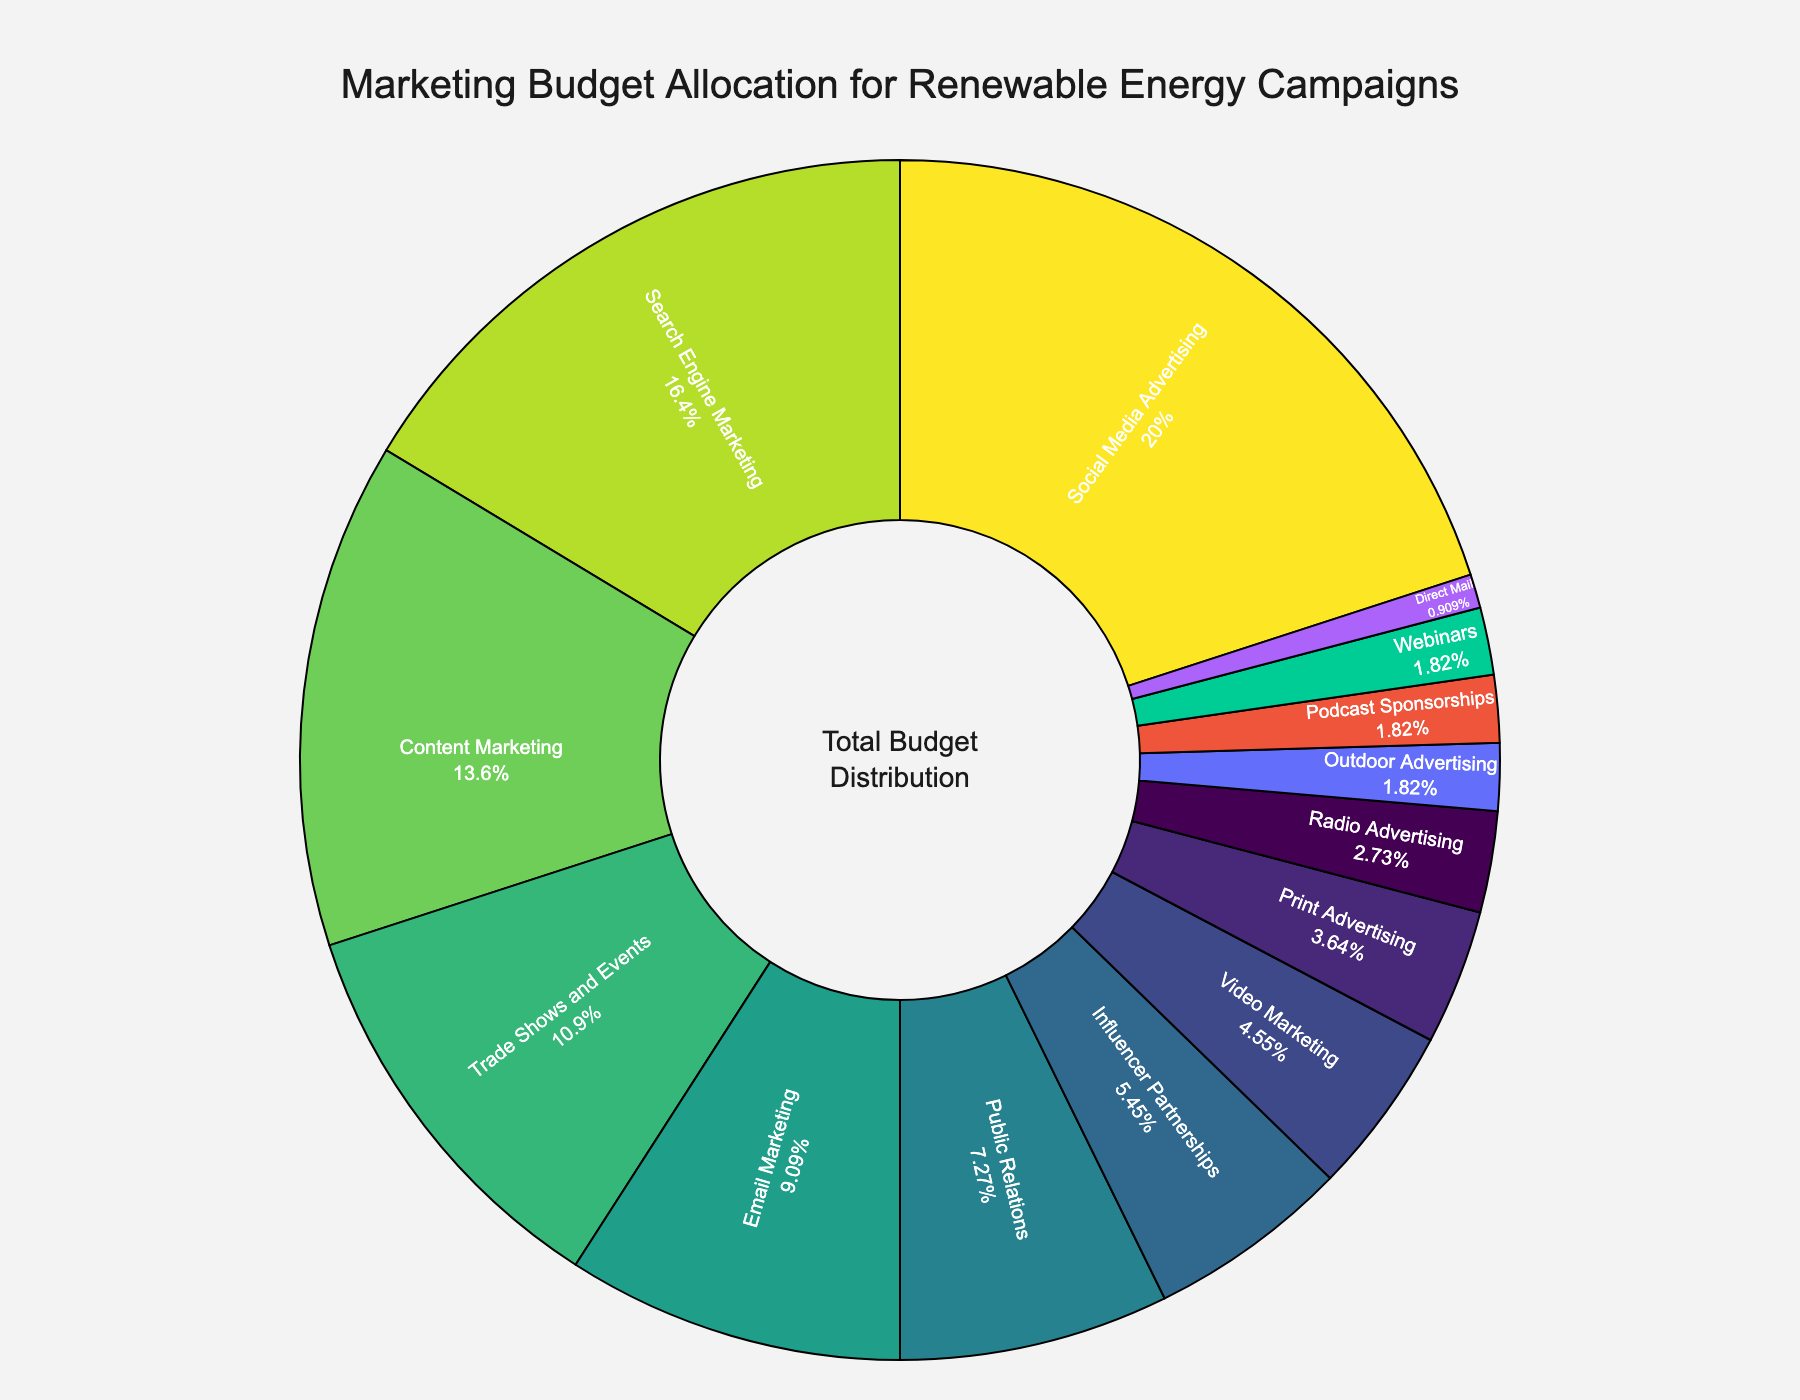What percentage is allocated to Social Media Advertising? The pie chart indicates that Social Media Advertising is labeled with 22%.
Answer: 22% Which channel receives the least amount of budget allocation? The smallest slice on the pie chart is marked with 1% for Direct Mail.
Answer: Direct Mail What is the combined budget percentage for Podcast Sponsorships and Webinars? The pie chart shows that both Podcast Sponsorships and Webinars are allocated 2% each. Adding them together: 2% + 2% = 4%.
Answer: 4% How does the budget for Email Marketing compare to that for Trade Shows and Events? The pie chart indicates that Email Marketing has a 10% allocation while Trade Shows and Events have 12%. Comparing these, Trade Shows and Events have 2% more than Email Marketing.
Answer: Trade Shows and Events have 2% more Is the budget for Influencer Partnerships greater than, less than, or equal to Video Marketing? Influencer Partnerships have a 6% allocation whereas Video Marketing has 5%. Thus, Influencer Partnerships have a larger percentage.
Answer: Greater than What is the total percentage of budget allocation for channels that have less than 5%? Channels with less than 5% are Video Marketing (5%), Print Advertising (4%), Radio Advertising (3%), Outdoor Advertising (2%), Podcast Sponsorships (2%), Webinars (2%), and Direct Mail (1%). Adding these together: 4% + 3% + 2% + 2% + 2% + 1% = 14%.
Answer: 14% What is the difference in budget allocation between Search Engine Marketing and Content Marketing? The pie chart indicates that Search Engine Marketing is allocated 18%, and Content Marketing is allocated 15%. The difference is 18% - 15% = 3%.
Answer: 3% Can you list the top three channels with the highest budget allocations in descending order? From the pie chart, the channels with the highest budget allocations are Social Media Advertising (22%), Search Engine Marketing (18%), and Content Marketing (15%).
Answer: Social Media Advertising, Search Engine Marketing, Content Marketing How does the percentage allocated to Public Relations compare to that of Trade Shows and Events? Public Relations is allocated 8% whereas Trade Shows and Events are at 12%. Therefore, Public Relations has 4% less than Trade Shows and Events.
Answer: 4% less 